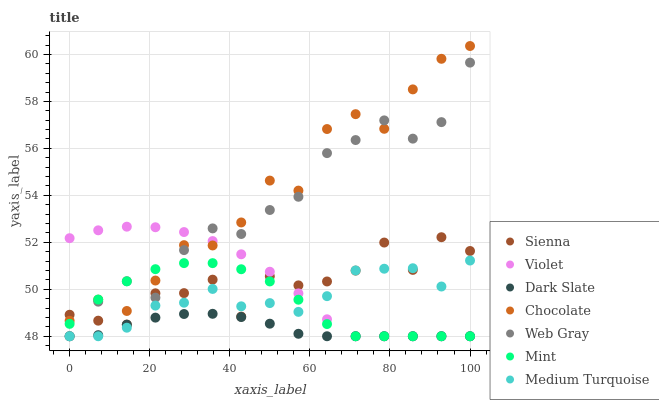Does Dark Slate have the minimum area under the curve?
Answer yes or no. Yes. Does Chocolate have the maximum area under the curve?
Answer yes or no. Yes. Does Sienna have the minimum area under the curve?
Answer yes or no. No. Does Sienna have the maximum area under the curve?
Answer yes or no. No. Is Dark Slate the smoothest?
Answer yes or no. Yes. Is Sienna the roughest?
Answer yes or no. Yes. Is Chocolate the smoothest?
Answer yes or no. No. Is Chocolate the roughest?
Answer yes or no. No. Does Web Gray have the lowest value?
Answer yes or no. Yes. Does Sienna have the lowest value?
Answer yes or no. No. Does Chocolate have the highest value?
Answer yes or no. Yes. Does Sienna have the highest value?
Answer yes or no. No. Is Medium Turquoise less than Chocolate?
Answer yes or no. Yes. Is Sienna greater than Dark Slate?
Answer yes or no. Yes. Does Mint intersect Web Gray?
Answer yes or no. Yes. Is Mint less than Web Gray?
Answer yes or no. No. Is Mint greater than Web Gray?
Answer yes or no. No. Does Medium Turquoise intersect Chocolate?
Answer yes or no. No. 